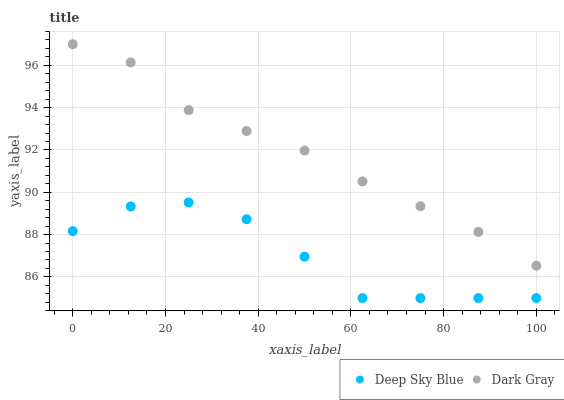Does Deep Sky Blue have the minimum area under the curve?
Answer yes or no. Yes. Does Dark Gray have the maximum area under the curve?
Answer yes or no. Yes. Does Deep Sky Blue have the maximum area under the curve?
Answer yes or no. No. Is Dark Gray the smoothest?
Answer yes or no. Yes. Is Deep Sky Blue the roughest?
Answer yes or no. Yes. Is Deep Sky Blue the smoothest?
Answer yes or no. No. Does Deep Sky Blue have the lowest value?
Answer yes or no. Yes. Does Dark Gray have the highest value?
Answer yes or no. Yes. Does Deep Sky Blue have the highest value?
Answer yes or no. No. Is Deep Sky Blue less than Dark Gray?
Answer yes or no. Yes. Is Dark Gray greater than Deep Sky Blue?
Answer yes or no. Yes. Does Deep Sky Blue intersect Dark Gray?
Answer yes or no. No. 